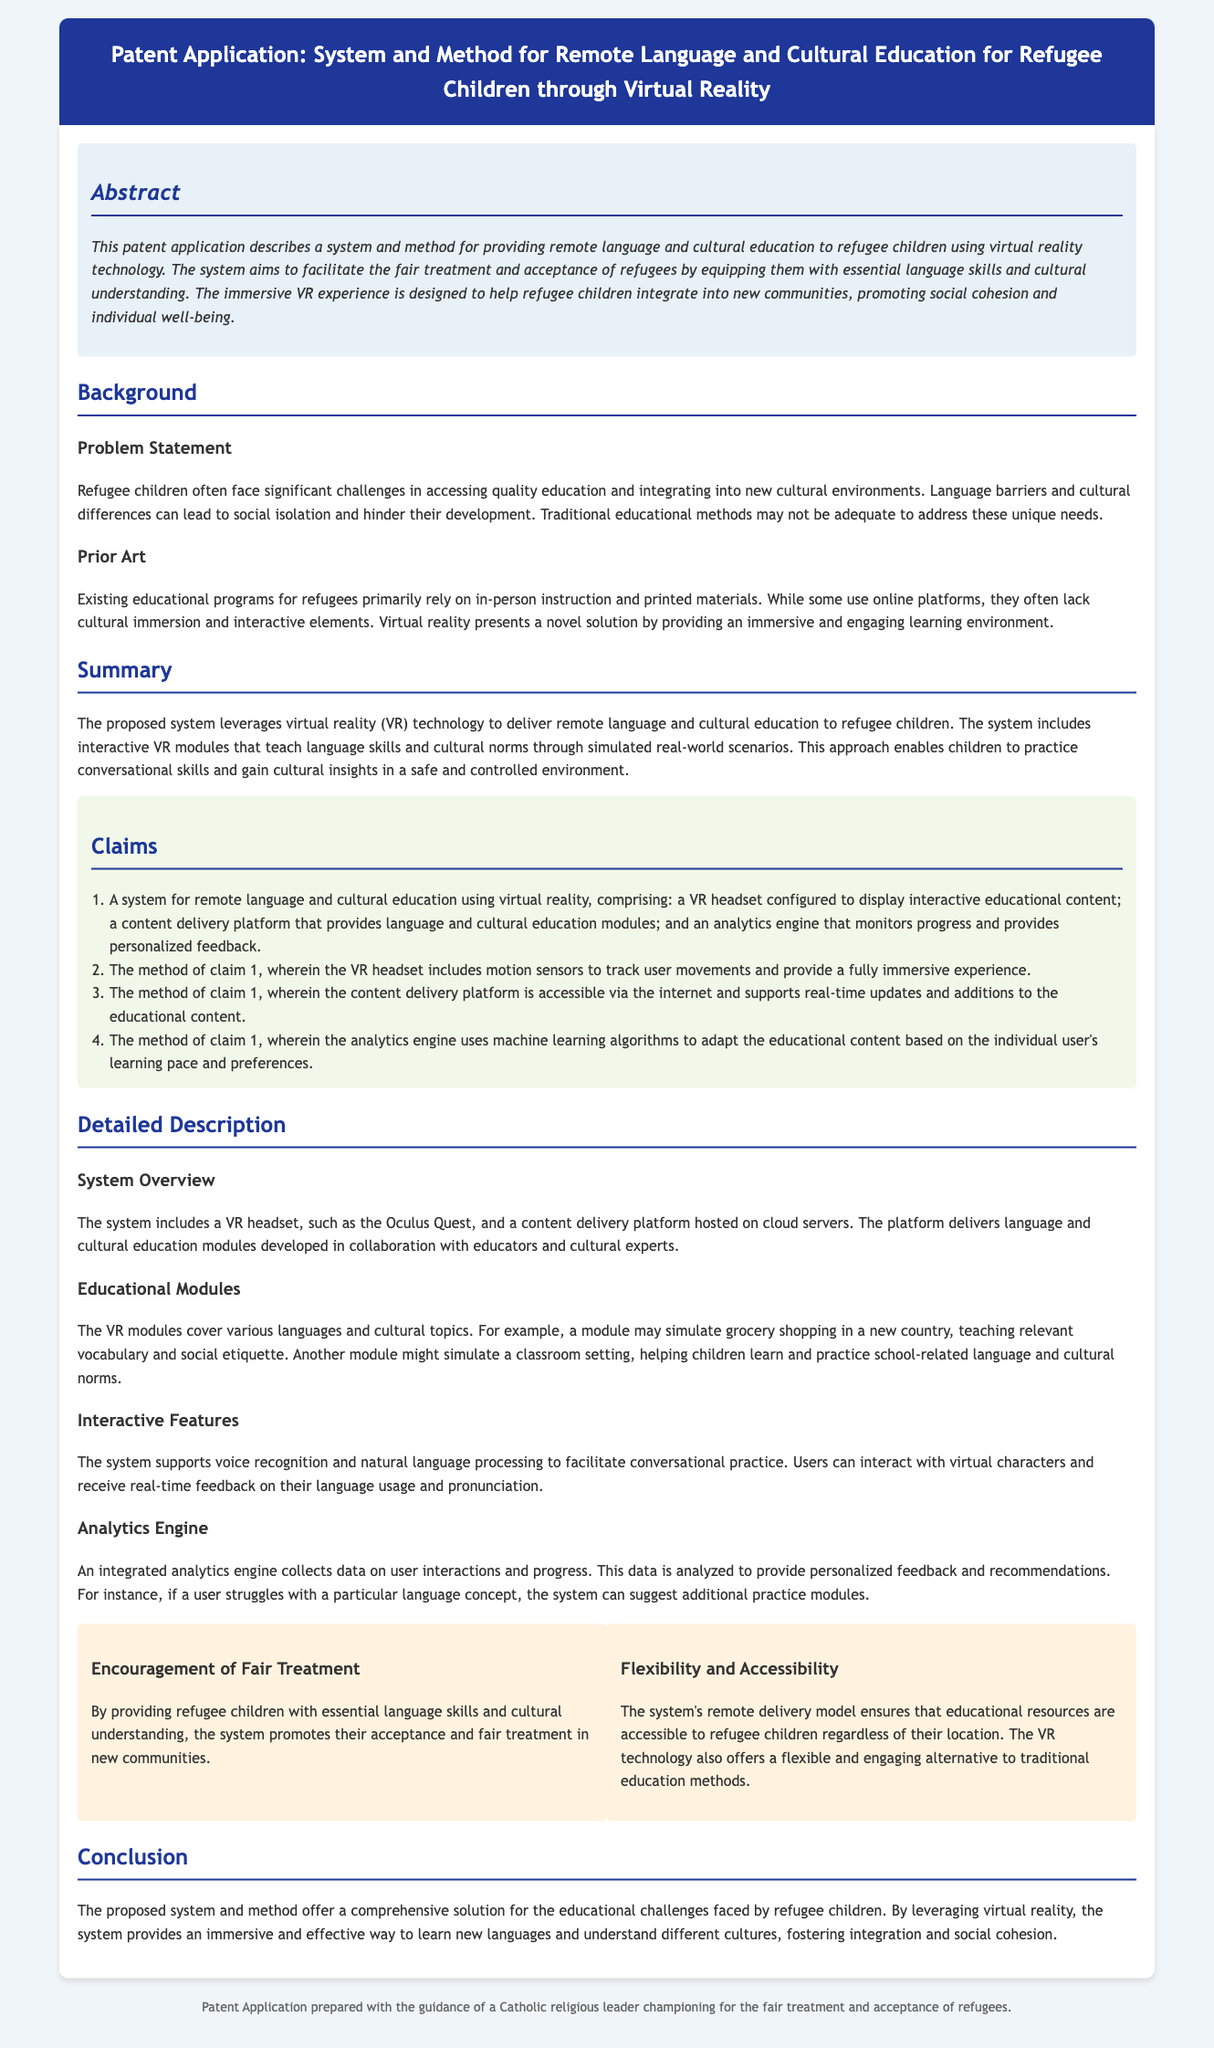What is the main technology used in the system? The system utilizes virtual reality technology to facilitate education.
Answer: virtual reality What is the purpose of the analytics engine? The analytics engine monitors progress and provides personalized feedback to users based on their interactions.
Answer: personalized feedback How many claims are detailed in the document? The document enumerates four specific claims related to the system and its method.
Answer: four What challenges do refugee children face according to the problem statement? Refugee children face challenges in accessing quality education and integrating into new cultural environments.
Answer: accessing quality education What is one key benefit of this system mentioned in the document? One of the benefits is that it promotes acceptance and fair treatment of refugee children in new communities.
Answer: fair treatment What can a VR module simulate for educational purposes? A VR module can simulate grocery shopping to teach relevant vocabulary and social etiquette.
Answer: grocery shopping Which feature allows users to practice conversations in the VR system? The system includes voice recognition and natural language processing to facilitate conversational practice.
Answer: conversational practice Who guided the preparation of this patent application? The patent application was prepared with the guidance of a Catholic religious leader.
Answer: Catholic religious leader 